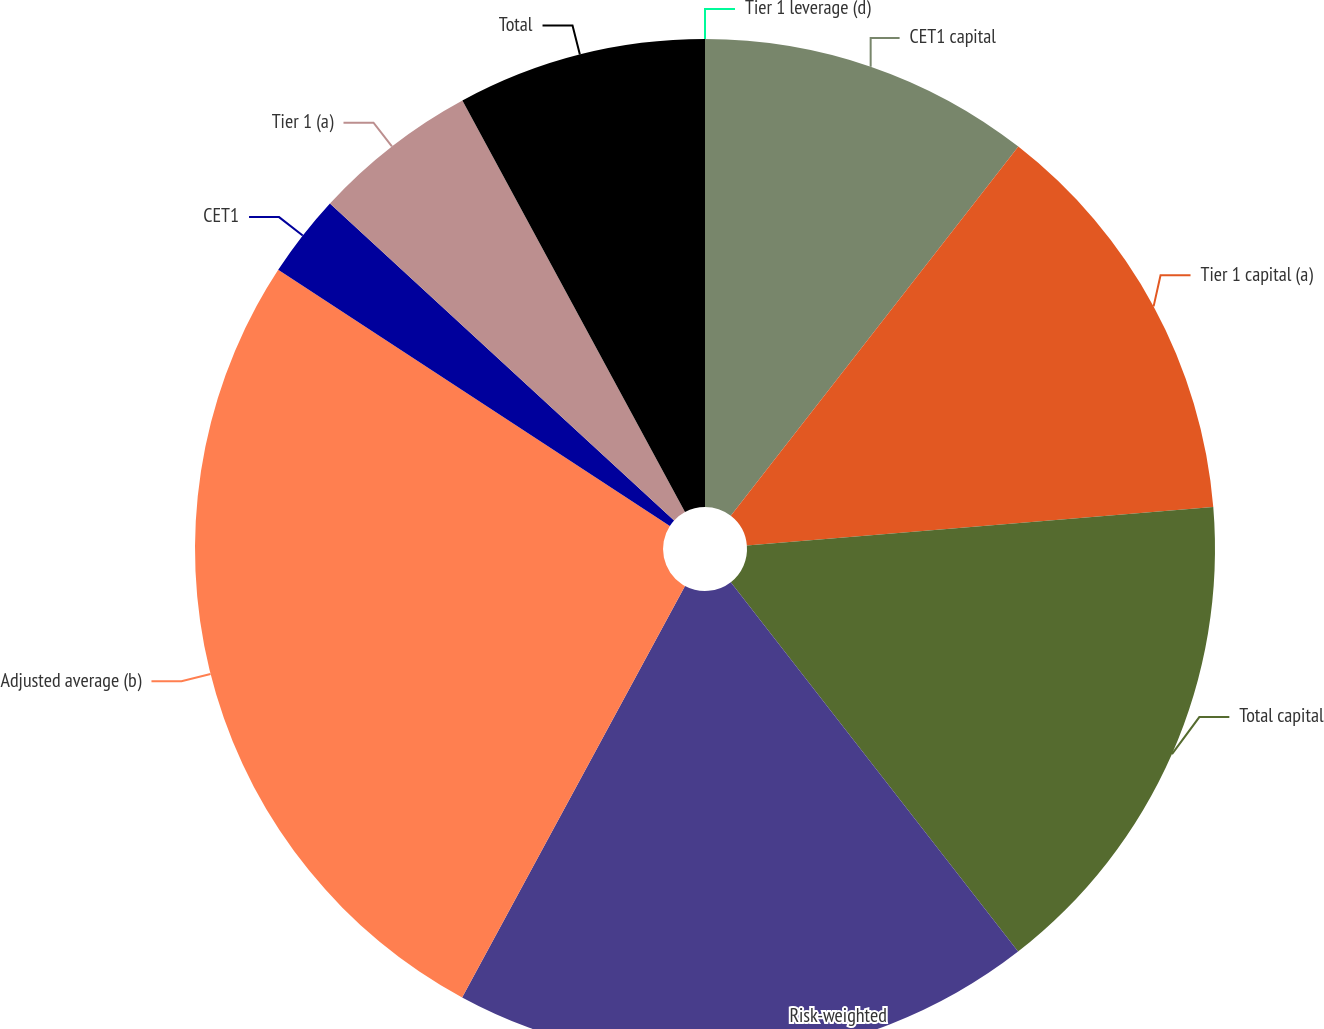Convert chart. <chart><loc_0><loc_0><loc_500><loc_500><pie_chart><fcel>CET1 capital<fcel>Tier 1 capital (a)<fcel>Total capital<fcel>Risk-weighted<fcel>Adjusted average (b)<fcel>CET1<fcel>Tier 1 (a)<fcel>Total<fcel>Tier 1 leverage (d)<nl><fcel>10.53%<fcel>13.16%<fcel>15.79%<fcel>18.42%<fcel>26.32%<fcel>2.63%<fcel>5.26%<fcel>7.89%<fcel>0.0%<nl></chart> 